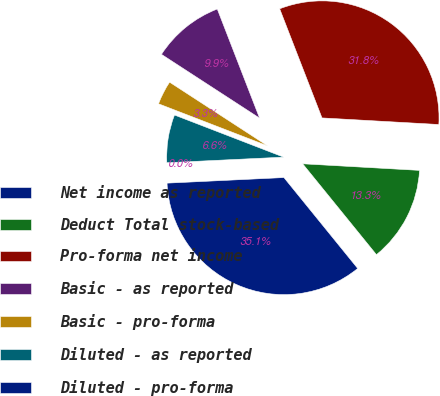Convert chart. <chart><loc_0><loc_0><loc_500><loc_500><pie_chart><fcel>Net income as reported<fcel>Deduct Total stock-based<fcel>Pro-forma net income<fcel>Basic - as reported<fcel>Basic - pro-forma<fcel>Diluted - as reported<fcel>Diluted - pro-forma<nl><fcel>35.09%<fcel>13.25%<fcel>31.78%<fcel>9.94%<fcel>3.31%<fcel>6.62%<fcel>0.0%<nl></chart> 